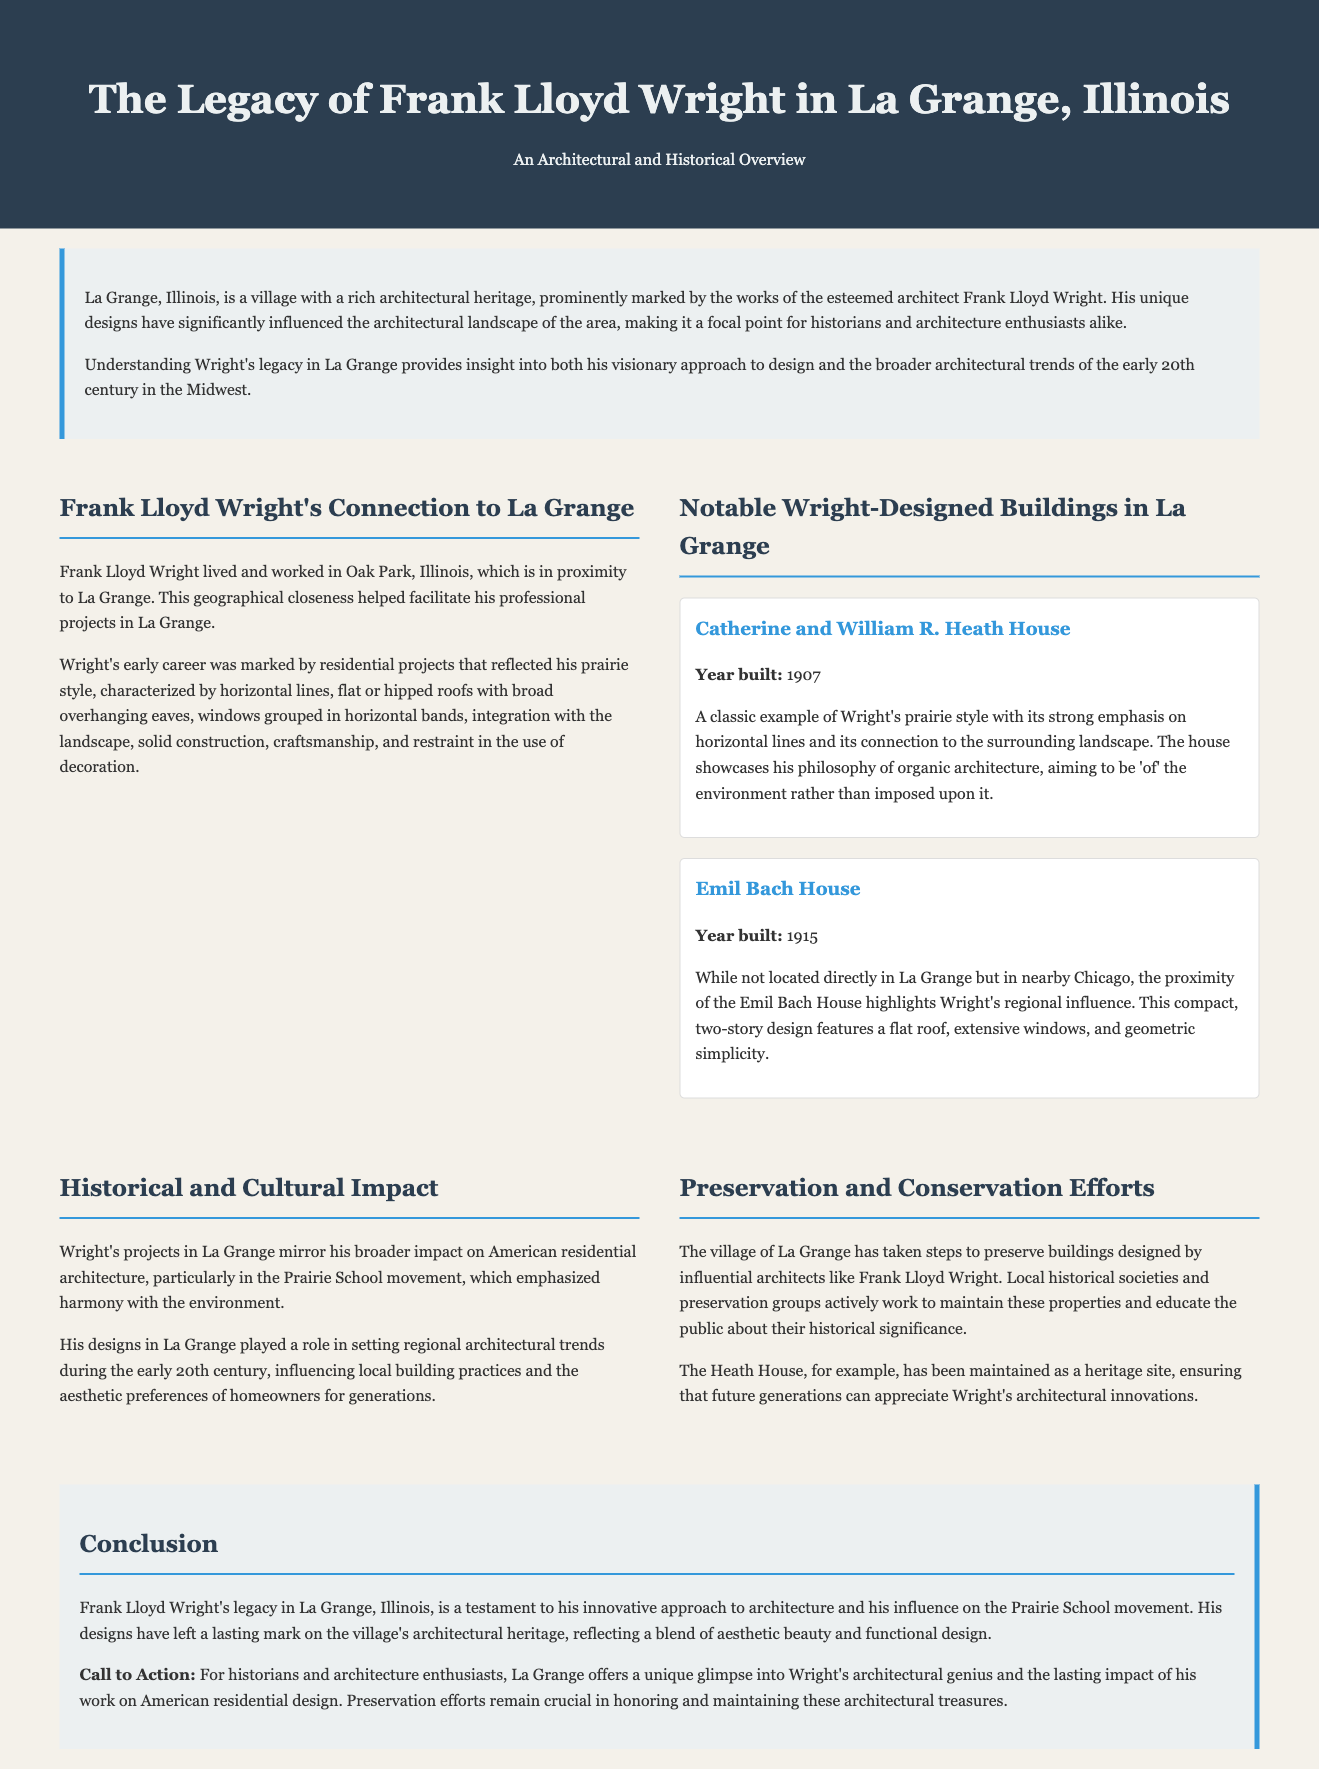what year was the Catherine and William R. Heath House built? The document states that the Heath House was built in 1907.
Answer: 1907 what style is the Heath House an example of? The document describes the Heath House as a classic example of Wright's prairie style.
Answer: prairie style which two buildings are specifically mentioned in the document? The document lists the Catherine and William R. Heath House and the Emil Bach House as notable buildings.
Answer: Catherine and William R. Heath House, Emil Bach House what movement does Wright's work in La Grange reflect? The document mentions that his projects mirror the Prairie School movement.
Answer: Prairie School movement what was a key characteristic of Wright's early residential projects? The document highlights that his early projects reflected horizontal lines as a key characteristic.
Answer: horizontal lines what has been done to preserve Wright's architectural designs in La Grange? The document explains that local historical societies and preservation groups work to maintain these properties.
Answer: maintain these properties how does the document describe Wright's design philosophy? The document states that Wright aimed to be 'of' the environment rather than imposed upon it.
Answer: 'of' the environment what is emphasized about Wright's influence on American architecture? The document notes that his designs in La Grange influenced local building practices and aesthetic preferences.
Answer: influenced local building practices and aesthetic preferences what call to action does the document promote for historians? The conclusion encourages historians and architecture enthusiasts to appreciate Wright’s architectural genius.
Answer: appreciate Wright’s architectural genius 